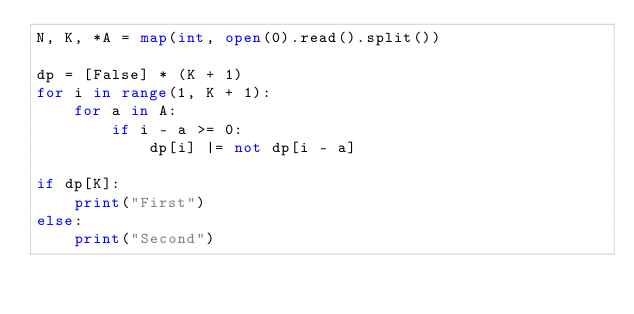Convert code to text. <code><loc_0><loc_0><loc_500><loc_500><_Python_>N, K, *A = map(int, open(0).read().split())

dp = [False] * (K + 1)
for i in range(1, K + 1):
    for a in A:
        if i - a >= 0:
            dp[i] |= not dp[i - a]

if dp[K]:
    print("First")
else:
    print("Second")</code> 